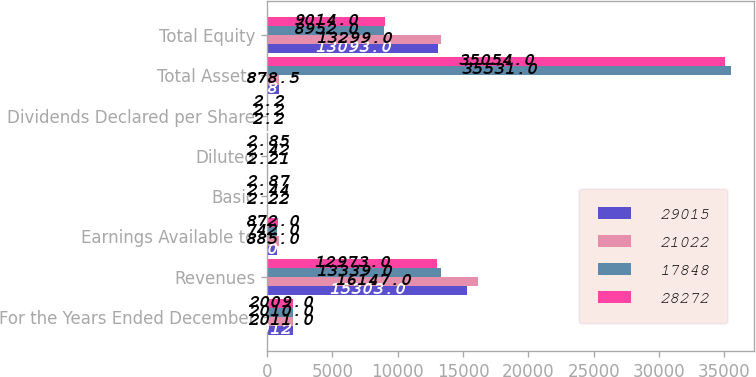Convert chart to OTSL. <chart><loc_0><loc_0><loc_500><loc_500><stacked_bar_chart><ecel><fcel>For the Years Ended December<fcel>Revenues<fcel>Earnings Available to<fcel>Basic<fcel>Diluted<fcel>Dividends Declared per Share<fcel>Total Assets<fcel>Total Equity<nl><fcel>29015<fcel>2012<fcel>15303<fcel>770<fcel>1.85<fcel>1.84<fcel>2.2<fcel>878.5<fcel>13093<nl><fcel>21022<fcel>2011<fcel>16147<fcel>885<fcel>2.22<fcel>2.21<fcel>2.2<fcel>878.5<fcel>13299<nl><fcel>17848<fcel>2010<fcel>13339<fcel>742<fcel>2.44<fcel>2.42<fcel>2.2<fcel>35531<fcel>8952<nl><fcel>28272<fcel>2009<fcel>12973<fcel>872<fcel>2.87<fcel>2.85<fcel>2.2<fcel>35054<fcel>9014<nl></chart> 